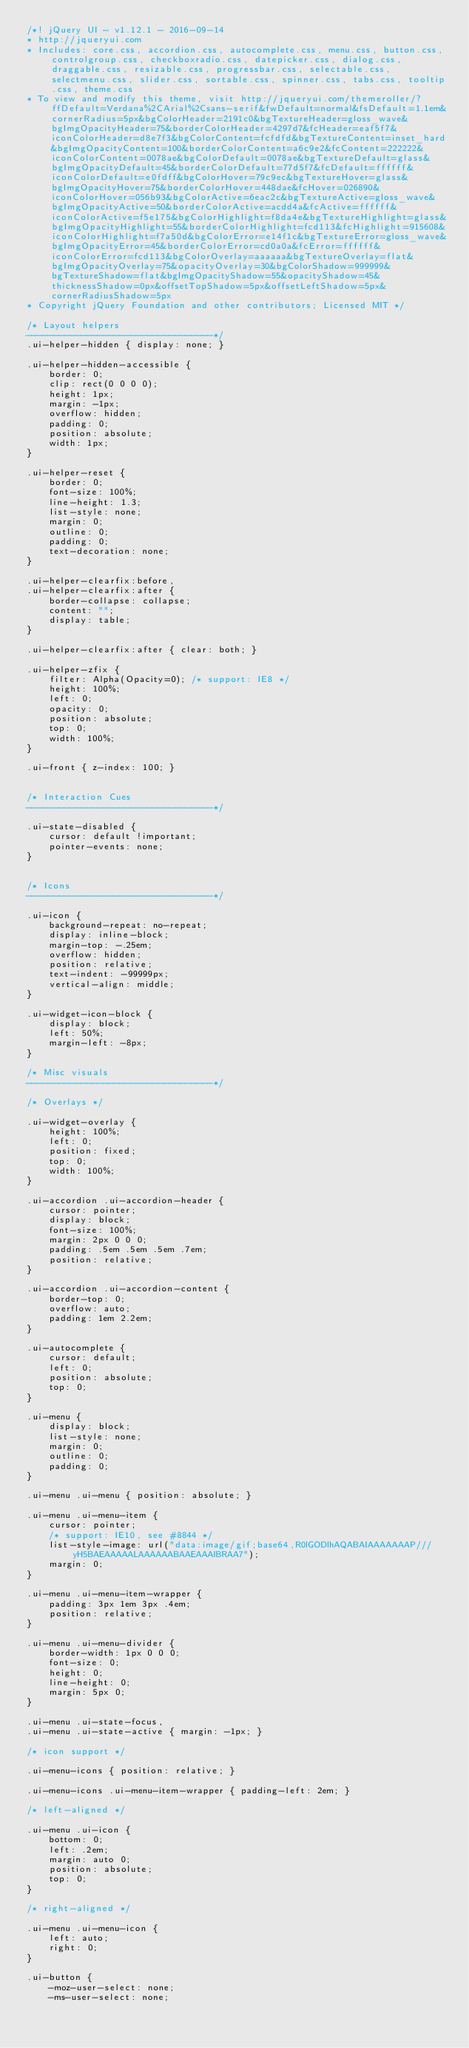<code> <loc_0><loc_0><loc_500><loc_500><_CSS_>/*! jQuery UI - v1.12.1 - 2016-09-14
* http://jqueryui.com
* Includes: core.css, accordion.css, autocomplete.css, menu.css, button.css, controlgroup.css, checkboxradio.css, datepicker.css, dialog.css, draggable.css, resizable.css, progressbar.css, selectable.css, selectmenu.css, slider.css, sortable.css, spinner.css, tabs.css, tooltip.css, theme.css
* To view and modify this theme, visit http://jqueryui.com/themeroller/?ffDefault=Verdana%2CArial%2Csans-serif&fwDefault=normal&fsDefault=1.1em&cornerRadius=5px&bgColorHeader=2191c0&bgTextureHeader=gloss_wave&bgImgOpacityHeader=75&borderColorHeader=4297d7&fcHeader=eaf5f7&iconColorHeader=d8e7f3&bgColorContent=fcfdfd&bgTextureContent=inset_hard&bgImgOpacityContent=100&borderColorContent=a6c9e2&fcContent=222222&iconColorContent=0078ae&bgColorDefault=0078ae&bgTextureDefault=glass&bgImgOpacityDefault=45&borderColorDefault=77d5f7&fcDefault=ffffff&iconColorDefault=e0fdff&bgColorHover=79c9ec&bgTextureHover=glass&bgImgOpacityHover=75&borderColorHover=448dae&fcHover=026890&iconColorHover=056b93&bgColorActive=6eac2c&bgTextureActive=gloss_wave&bgImgOpacityActive=50&borderColorActive=acdd4a&fcActive=ffffff&iconColorActive=f5e175&bgColorHighlight=f8da4e&bgTextureHighlight=glass&bgImgOpacityHighlight=55&borderColorHighlight=fcd113&fcHighlight=915608&iconColorHighlight=f7a50d&bgColorError=e14f1c&bgTextureError=gloss_wave&bgImgOpacityError=45&borderColorError=cd0a0a&fcError=ffffff&iconColorError=fcd113&bgColorOverlay=aaaaaa&bgTextureOverlay=flat&bgImgOpacityOverlay=75&opacityOverlay=30&bgColorShadow=999999&bgTextureShadow=flat&bgImgOpacityShadow=55&opacityShadow=45&thicknessShadow=0px&offsetTopShadow=5px&offsetLeftShadow=5px&cornerRadiusShadow=5px
* Copyright jQuery Foundation and other contributors; Licensed MIT */

/* Layout helpers
----------------------------------*/
.ui-helper-hidden { display: none; }

.ui-helper-hidden-accessible {
    border: 0;
    clip: rect(0 0 0 0);
    height: 1px;
    margin: -1px;
    overflow: hidden;
    padding: 0;
    position: absolute;
    width: 1px;
}

.ui-helper-reset {
    border: 0;
    font-size: 100%;
    line-height: 1.3;
    list-style: none;
    margin: 0;
    outline: 0;
    padding: 0;
    text-decoration: none;
}

.ui-helper-clearfix:before,
.ui-helper-clearfix:after {
    border-collapse: collapse;
    content: "";
    display: table;
}

.ui-helper-clearfix:after { clear: both; }

.ui-helper-zfix {
    filter: Alpha(Opacity=0); /* support: IE8 */
    height: 100%;
    left: 0;
    opacity: 0;
    position: absolute;
    top: 0;
    width: 100%;
}

.ui-front { z-index: 100; }


/* Interaction Cues
----------------------------------*/

.ui-state-disabled {
    cursor: default !important;
    pointer-events: none;
}


/* Icons
----------------------------------*/

.ui-icon {
    background-repeat: no-repeat;
    display: inline-block;
    margin-top: -.25em;
    overflow: hidden;
    position: relative;
    text-indent: -99999px;
    vertical-align: middle;
}

.ui-widget-icon-block {
    display: block;
    left: 50%;
    margin-left: -8px;
}

/* Misc visuals
----------------------------------*/

/* Overlays */

.ui-widget-overlay {
    height: 100%;
    left: 0;
    position: fixed;
    top: 0;
    width: 100%;
}

.ui-accordion .ui-accordion-header {
    cursor: pointer;
    display: block;
    font-size: 100%;
    margin: 2px 0 0 0;
    padding: .5em .5em .5em .7em;
    position: relative;
}

.ui-accordion .ui-accordion-content {
    border-top: 0;
    overflow: auto;
    padding: 1em 2.2em;
}

.ui-autocomplete {
    cursor: default;
    left: 0;
    position: absolute;
    top: 0;
}

.ui-menu {
    display: block;
    list-style: none;
    margin: 0;
    outline: 0;
    padding: 0;
}

.ui-menu .ui-menu { position: absolute; }

.ui-menu .ui-menu-item {
    cursor: pointer;
    /* support: IE10, see #8844 */
    list-style-image: url("data:image/gif;base64,R0lGODlhAQABAIAAAAAAAP///yH5BAEAAAAALAAAAAABAAEAAAIBRAA7");
    margin: 0;
}

.ui-menu .ui-menu-item-wrapper {
    padding: 3px 1em 3px .4em;
    position: relative;
}

.ui-menu .ui-menu-divider {
    border-width: 1px 0 0 0;
    font-size: 0;
    height: 0;
    line-height: 0;
    margin: 5px 0;
}

.ui-menu .ui-state-focus,
.ui-menu .ui-state-active { margin: -1px; }

/* icon support */

.ui-menu-icons { position: relative; }

.ui-menu-icons .ui-menu-item-wrapper { padding-left: 2em; }

/* left-aligned */

.ui-menu .ui-icon {
    bottom: 0;
    left: .2em;
    margin: auto 0;
    position: absolute;
    top: 0;
}

/* right-aligned */

.ui-menu .ui-menu-icon {
    left: auto;
    right: 0;
}

.ui-button {
    -moz-user-select: none;
    -ms-user-select: none;</code> 